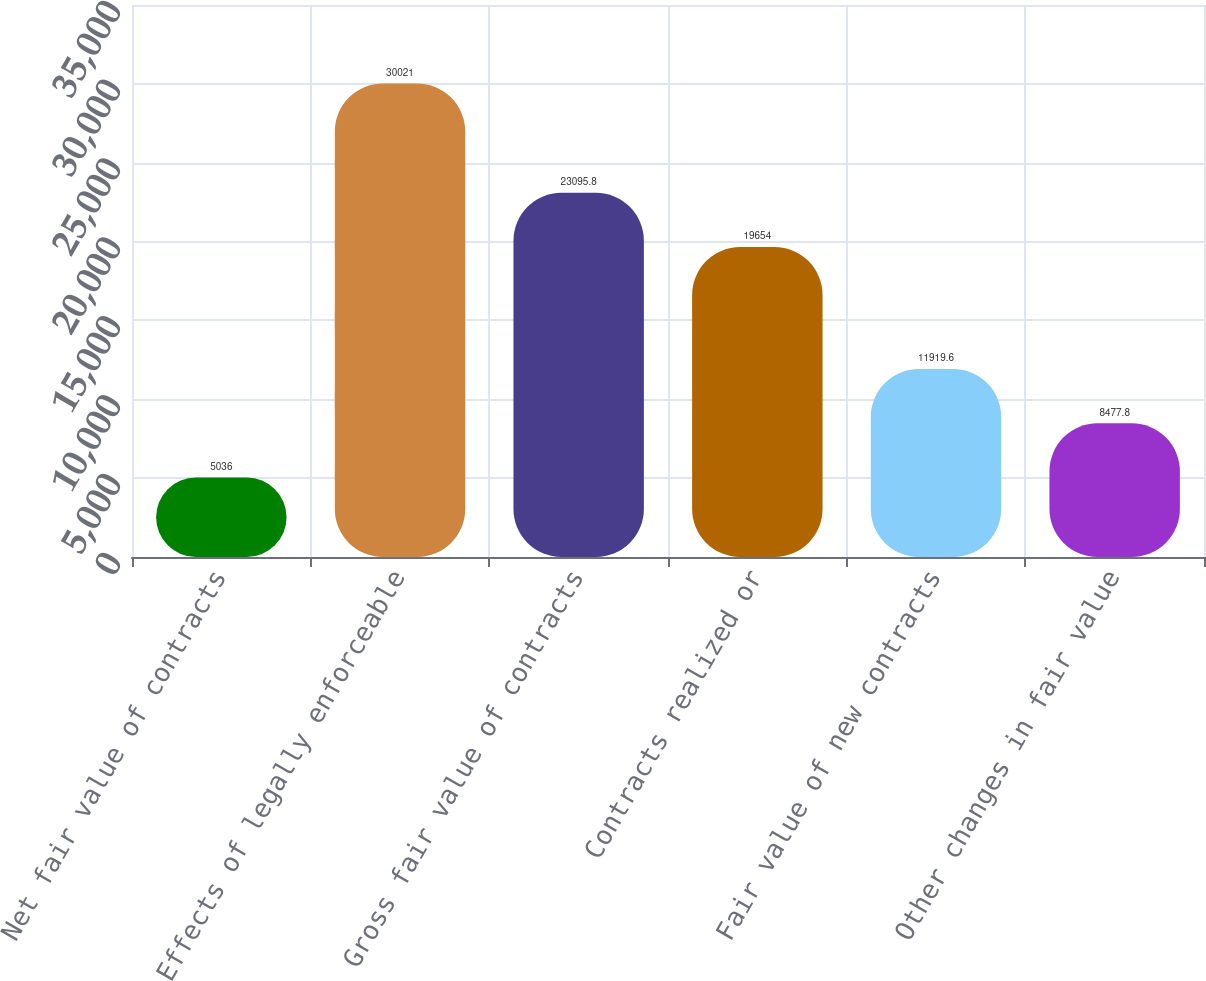Convert chart. <chart><loc_0><loc_0><loc_500><loc_500><bar_chart><fcel>Net fair value of contracts<fcel>Effects of legally enforceable<fcel>Gross fair value of contracts<fcel>Contracts realized or<fcel>Fair value of new contracts<fcel>Other changes in fair value<nl><fcel>5036<fcel>30021<fcel>23095.8<fcel>19654<fcel>11919.6<fcel>8477.8<nl></chart> 